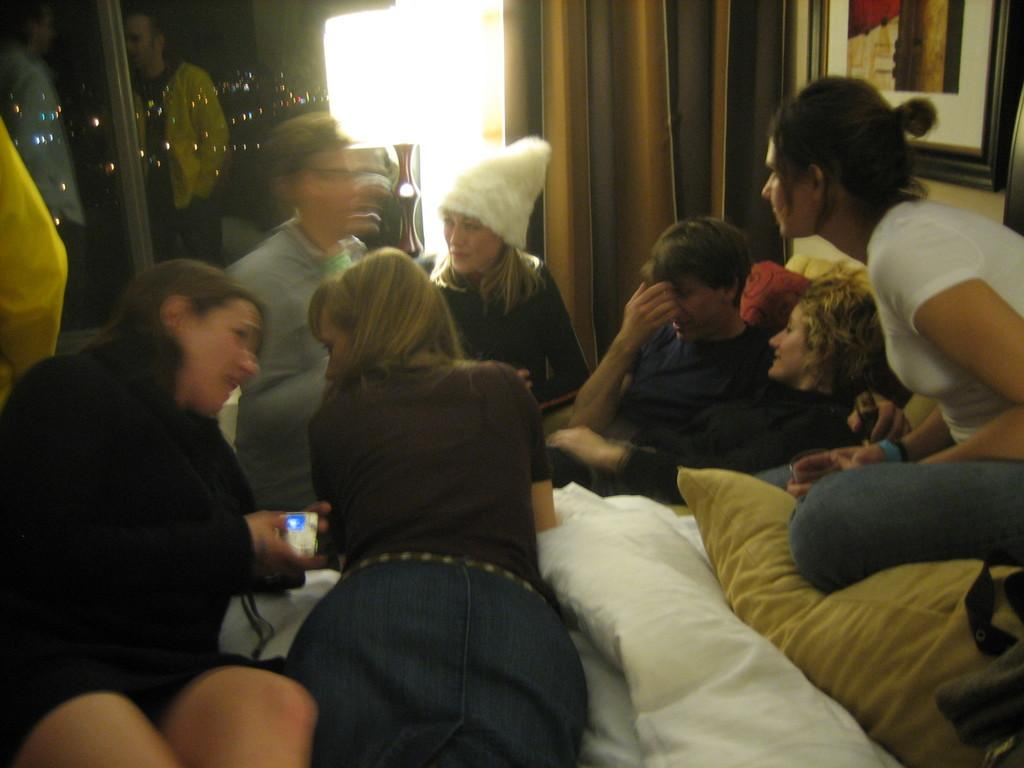How many people are in the image? There is a group of persons in the image. What are the persons doing in the image? The persons are lying on blankets and pillows. Where are the blankets and pillows located? The blankets and pillows are on a bed. What can be seen in the background of the image? There is a curtain, a lamp, and a frame attached to a wall in the background of the image. What type of apple is being used as a pillow in the image? There is no apple present in the image; the persons are lying on blankets and pillows. What is the oatmeal being used for in the image? There is no oatmeal present in the image. 